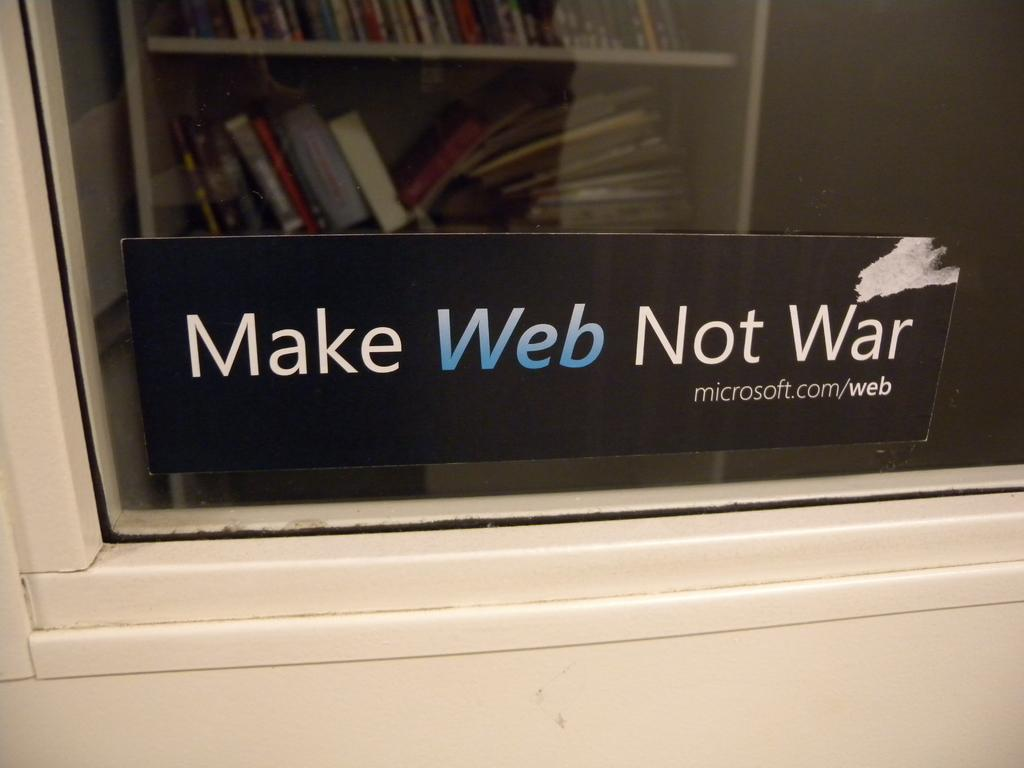<image>
Offer a succinct explanation of the picture presented. A Microsoft slogan says to "make web not war". 